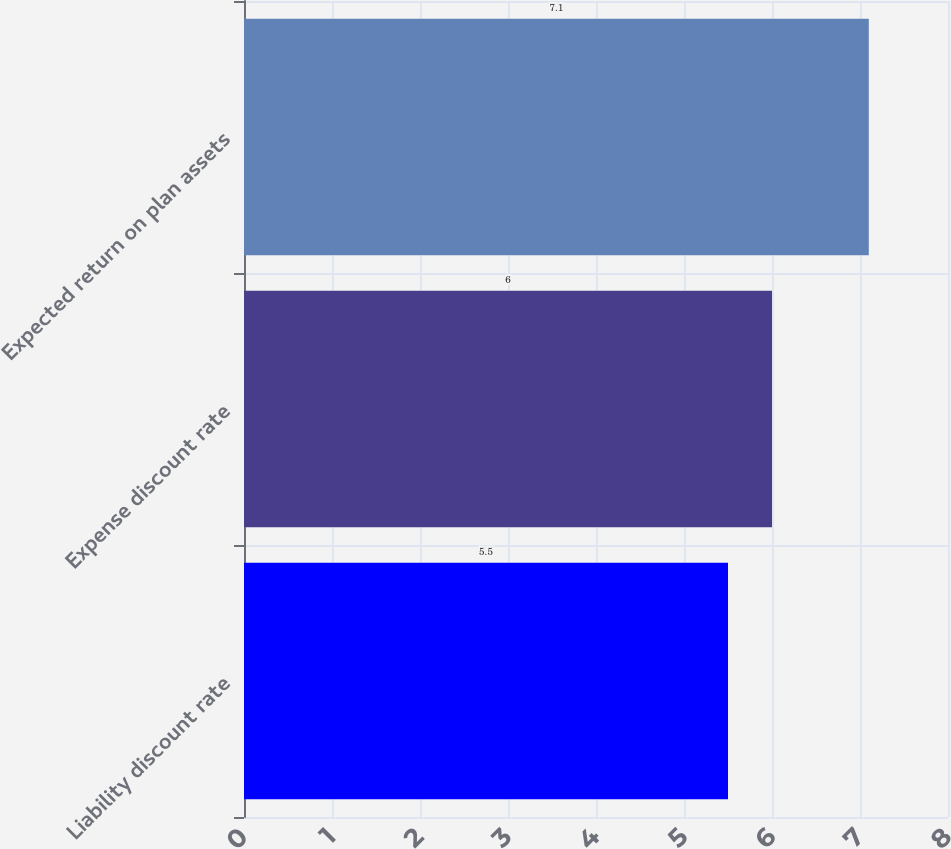Convert chart to OTSL. <chart><loc_0><loc_0><loc_500><loc_500><bar_chart><fcel>Liability discount rate<fcel>Expense discount rate<fcel>Expected return on plan assets<nl><fcel>5.5<fcel>6<fcel>7.1<nl></chart> 